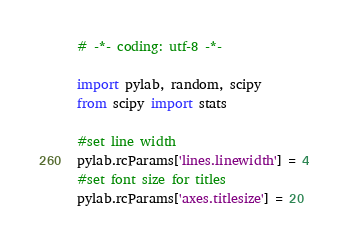<code> <loc_0><loc_0><loc_500><loc_500><_Python_># -*- coding: utf-8 -*-

import pylab, random, scipy
from scipy import stats

#set line width
pylab.rcParams['lines.linewidth'] = 4
#set font size for titles 
pylab.rcParams['axes.titlesize'] = 20</code> 